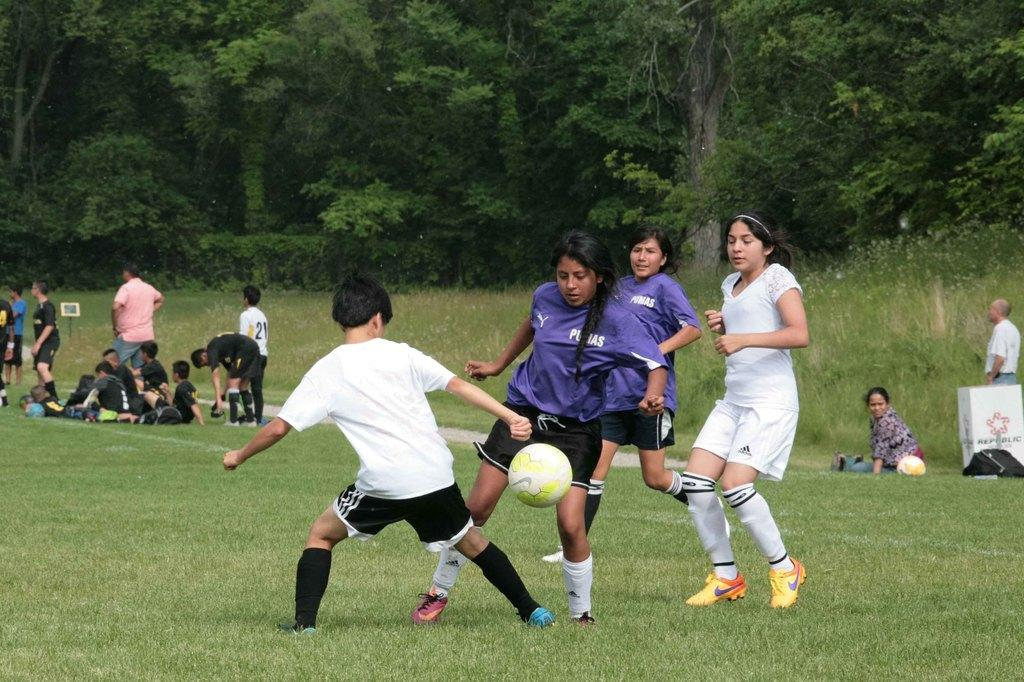How many people are playing football in the image? There are four people playing football in the image. What is the surface on which the football game is taking place? The football game is taking place on grass. Can you describe what is visible in the background of the image? In the background of the image, there are people, a ball, plants, objects, and trees. What type of hose is being used by one of the players to gain an advantage in the game? There is no hose present in the image, and no player is using any object to gain an advantage. 